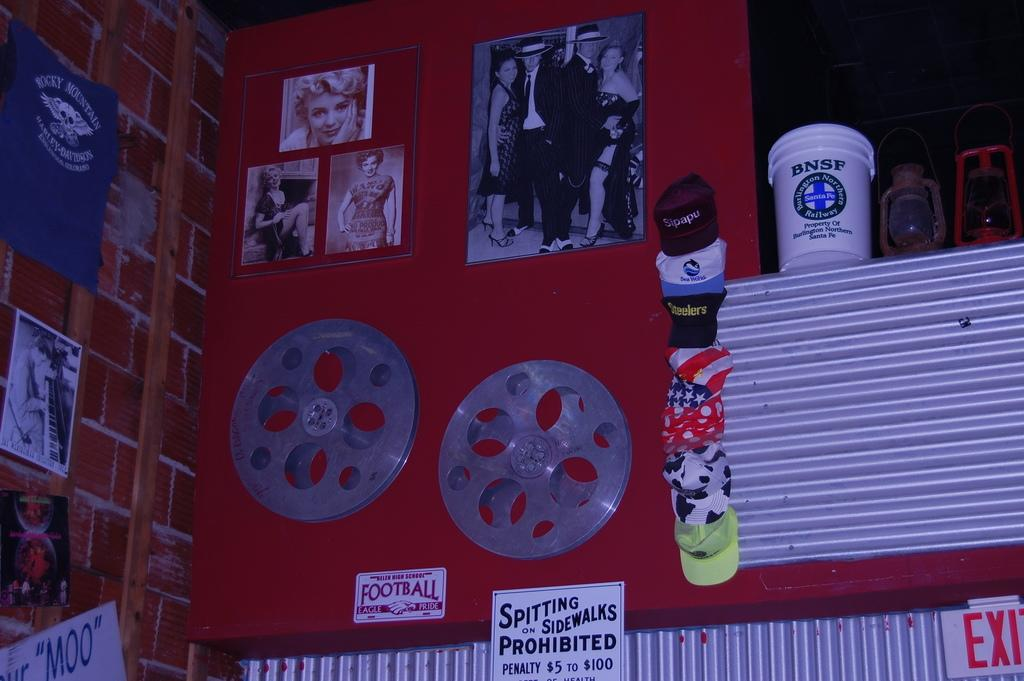<image>
Write a terse but informative summary of the picture. the side of a building with a sign that states sitting on the sidewalk is prohibitted 